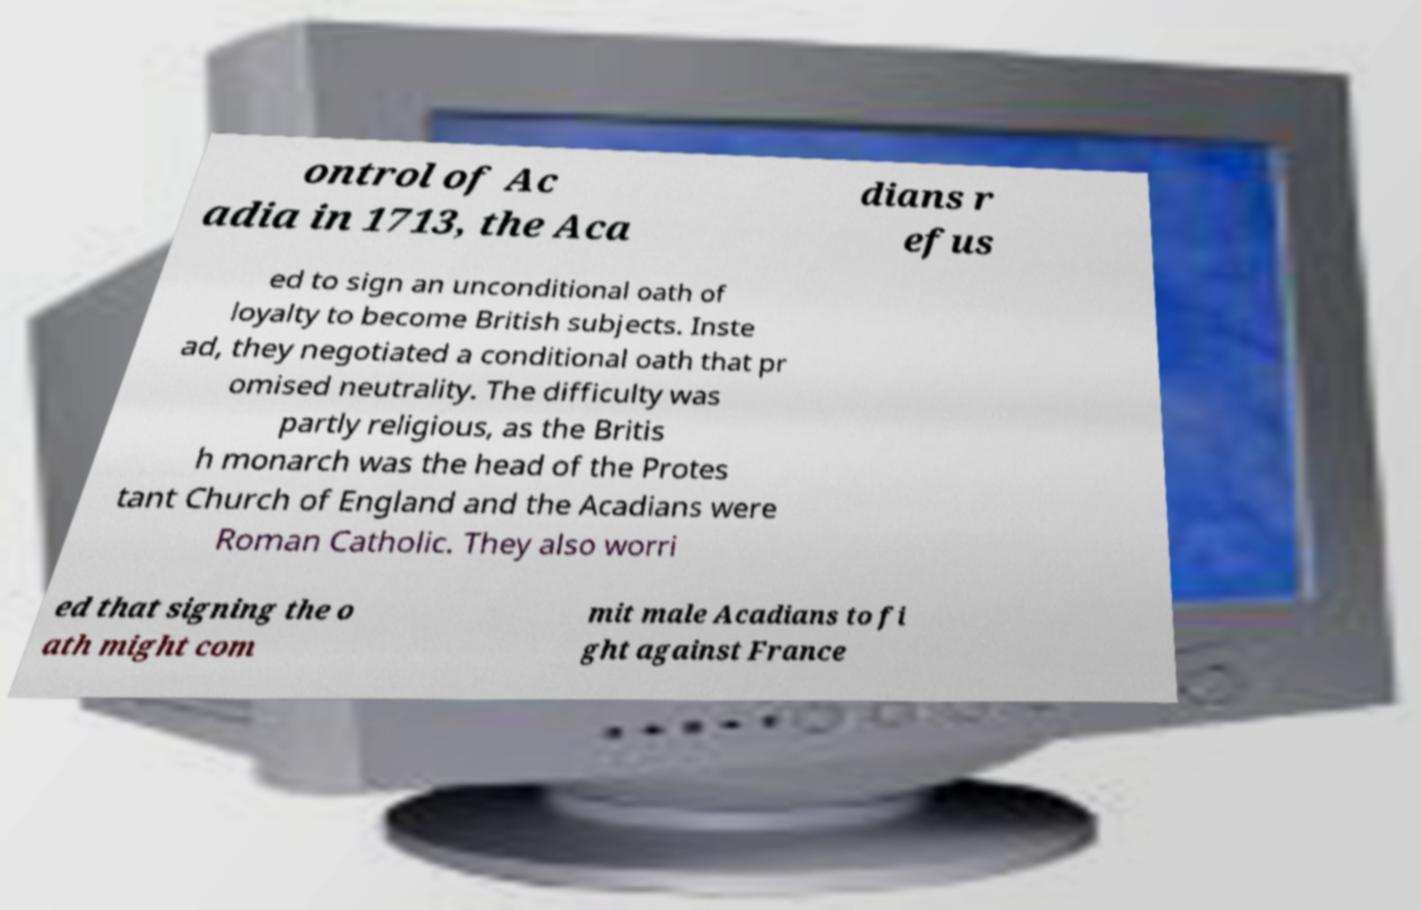Please identify and transcribe the text found in this image. ontrol of Ac adia in 1713, the Aca dians r efus ed to sign an unconditional oath of loyalty to become British subjects. Inste ad, they negotiated a conditional oath that pr omised neutrality. The difficulty was partly religious, as the Britis h monarch was the head of the Protes tant Church of England and the Acadians were Roman Catholic. They also worri ed that signing the o ath might com mit male Acadians to fi ght against France 